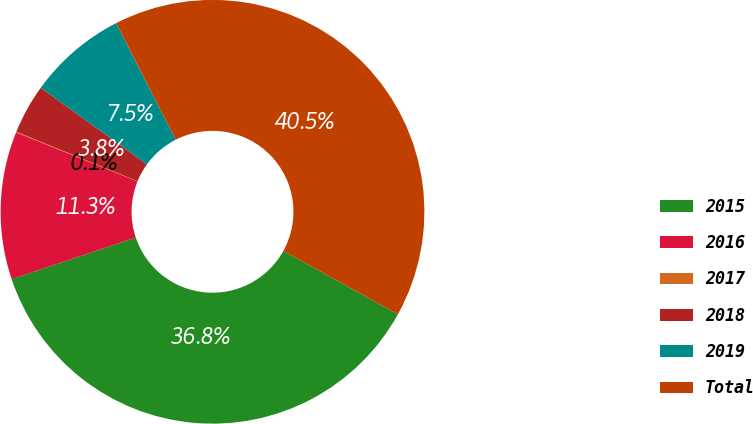<chart> <loc_0><loc_0><loc_500><loc_500><pie_chart><fcel>2015<fcel>2016<fcel>2017<fcel>2018<fcel>2019<fcel>Total<nl><fcel>36.81%<fcel>11.27%<fcel>0.05%<fcel>3.79%<fcel>7.53%<fcel>40.55%<nl></chart> 